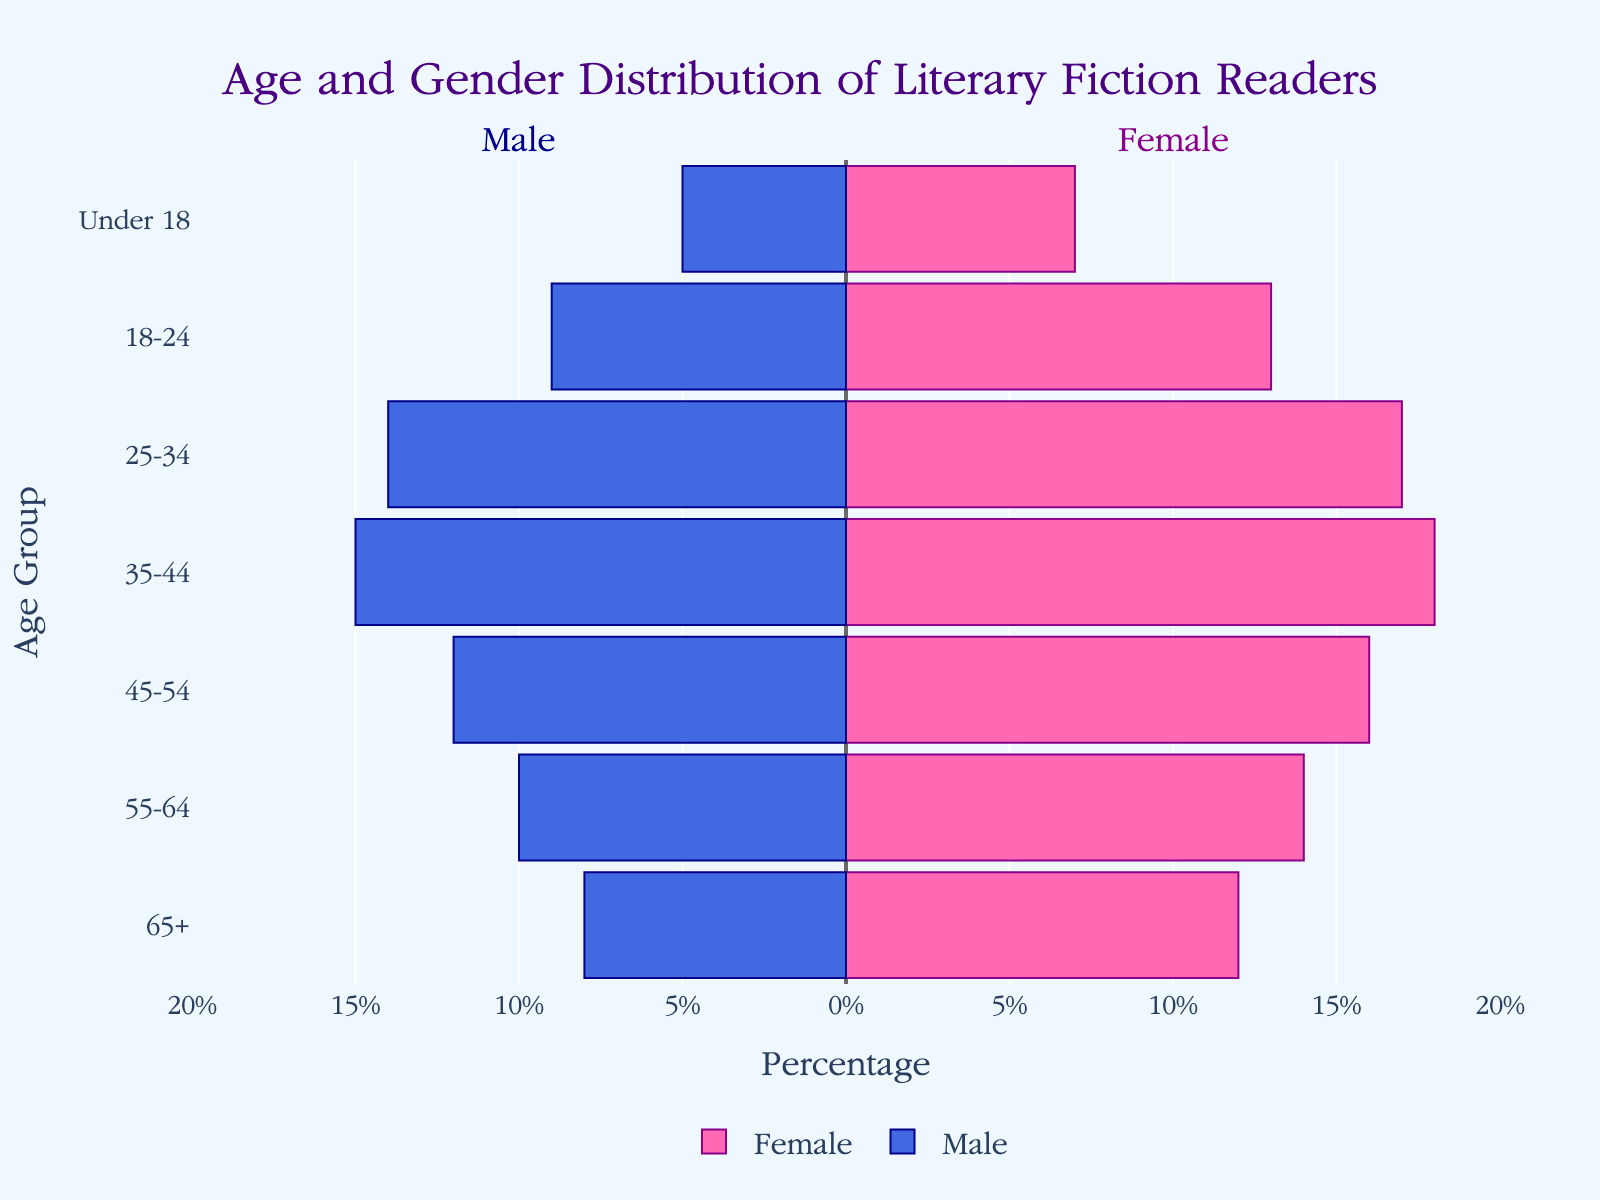What is the title of the figure? The title is located at the top of the figure and provides an overview of what the figure is about.
Answer: Age and Gender Distribution of Literary Fiction Readers What age group has the highest percentage of female readers? Refer to the bars that represent females and identify the age group with the longest bar.
Answer: 35-44 How many male readers are in the 45-54 age group? Look at the length of the male bar for the 45-54 age group; the negative axis indicates male values.
Answer: 12 Which age group shows the smallest gender gap in the number of readers? Compare the lengths of male and female bars across all age groups to find the smallest difference.
Answer: 18-24 What is the total number of readers in the 25-34 age group? Sum the number of male and female readers in the 25-34 age group.
Answer: 31 Which gender has more readers in the 55-64 age group? Compare the lengths of male and female bars in the 55-64 age group.
Answer: Female How many more female readers are there than male readers in the 65+ age group? Subtract the number of male readers from the number of female readers in the 65+ age group.
Answer: 4 What age group has the highest number of male readers? Identify the age group with the longest male bar.
Answer: 35-44 Which age group has the lowest total number of readers? Find the age group with the sum of male and female readers being the smallest.
Answer: Under 18 Are there more readers in the 18-24 age group compared to the 55-64 age group? Compare the total number of readers in both the 18-24 and 55-64 age groups.
Answer: No 